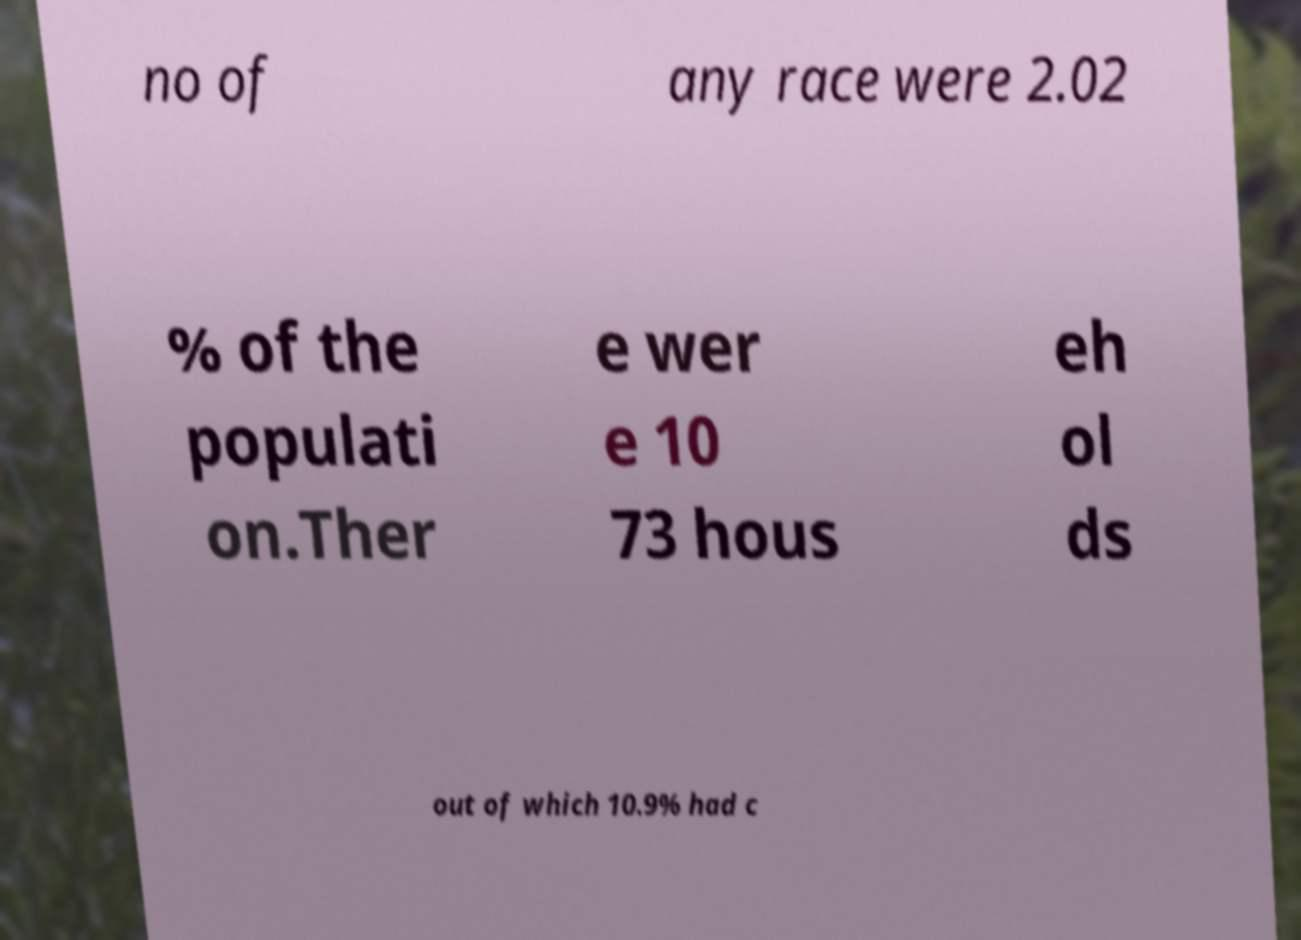Can you read and provide the text displayed in the image?This photo seems to have some interesting text. Can you extract and type it out for me? no of any race were 2.02 % of the populati on.Ther e wer e 10 73 hous eh ol ds out of which 10.9% had c 